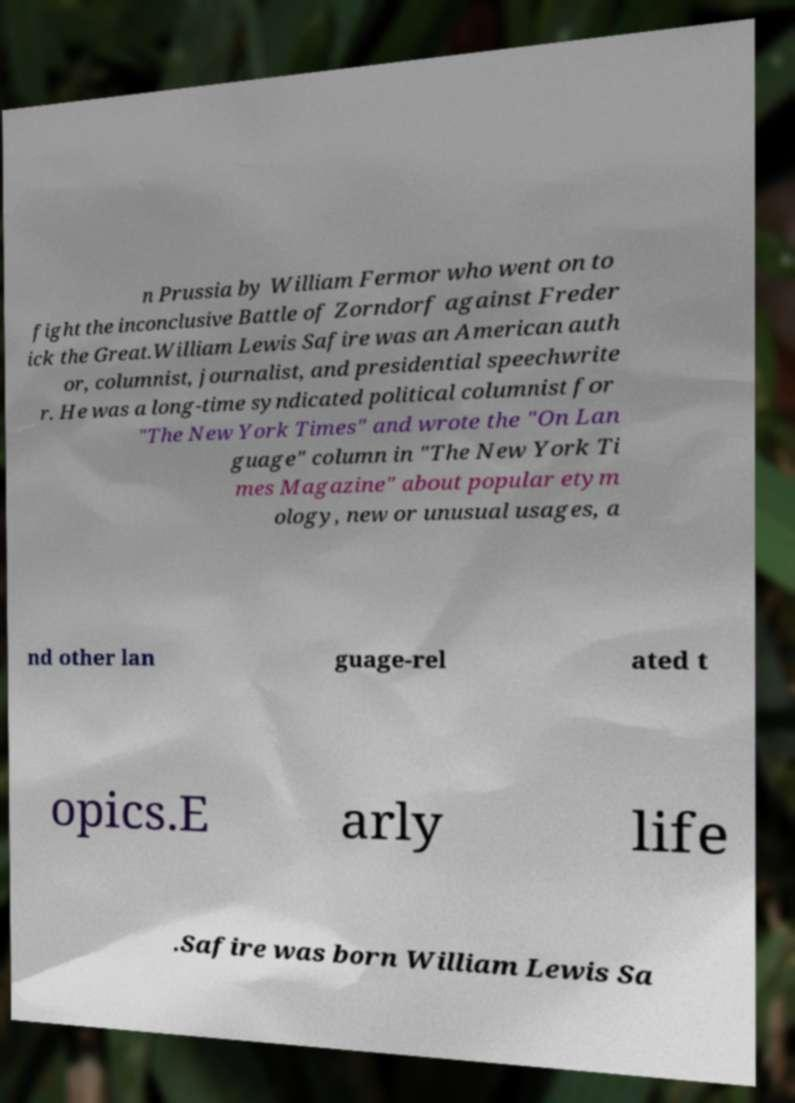Please read and relay the text visible in this image. What does it say? n Prussia by William Fermor who went on to fight the inconclusive Battle of Zorndorf against Freder ick the Great.William Lewis Safire was an American auth or, columnist, journalist, and presidential speechwrite r. He was a long-time syndicated political columnist for "The New York Times" and wrote the "On Lan guage" column in "The New York Ti mes Magazine" about popular etym ology, new or unusual usages, a nd other lan guage-rel ated t opics.E arly life .Safire was born William Lewis Sa 